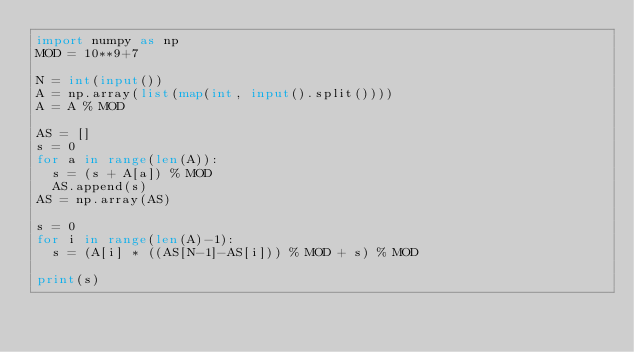Convert code to text. <code><loc_0><loc_0><loc_500><loc_500><_Python_>import numpy as np
MOD = 10**9+7

N = int(input())
A = np.array(list(map(int, input().split())))
A = A % MOD

AS = []
s = 0
for a in range(len(A)):
  s = (s + A[a]) % MOD
  AS.append(s)
AS = np.array(AS)

s = 0
for i in range(len(A)-1):
  s = (A[i] * ((AS[N-1]-AS[i])) % MOD + s) % MOD
  
print(s)</code> 